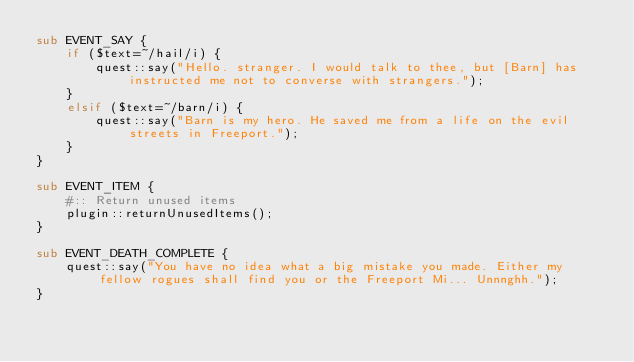<code> <loc_0><loc_0><loc_500><loc_500><_Perl_>sub EVENT_SAY {
	if ($text=~/hail/i) {
		quest::say("Hello. stranger. I would talk to thee, but [Barn] has instructed me not to converse with strangers.");
	}
	elsif ($text=~/barn/i) {
		quest::say("Barn is my hero. He saved me from a life on the evil streets in Freeport.");
	}
}

sub EVENT_ITEM {
	#:: Return unused items
	plugin::returnUnusedItems();
}

sub EVENT_DEATH_COMPLETE {
	quest::say("You have no idea what a big mistake you made. Either my fellow rogues shall find you or the Freeport Mi... Unnnghh.");
}
</code> 